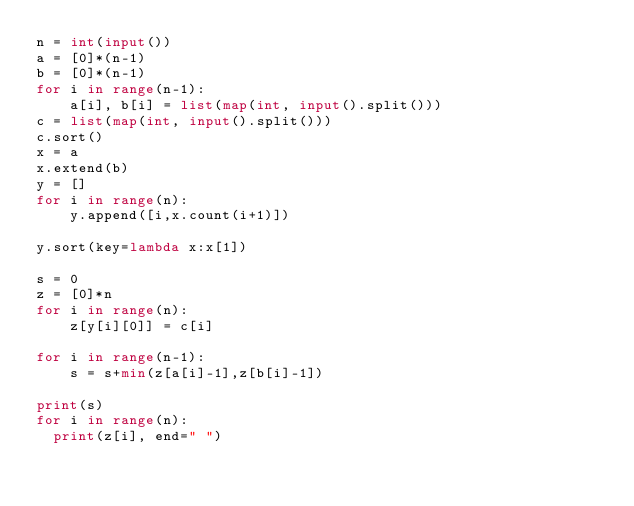Convert code to text. <code><loc_0><loc_0><loc_500><loc_500><_Python_>n = int(input())
a = [0]*(n-1)
b = [0]*(n-1)
for i in range(n-1):
    a[i], b[i] = list(map(int, input().split()))
c = list(map(int, input().split()))
c.sort()
x = a
x.extend(b)
y = []
for i in range(n):
    y.append([i,x.count(i+1)])

y.sort(key=lambda x:x[1])

s = 0
z = [0]*n
for i in range(n):
    z[y[i][0]] = c[i]
    
for i in range(n-1):
    s = s+min(z[a[i]-1],z[b[i]-1])

print(s)
for i in range(n):
  print(z[i], end=" ")</code> 